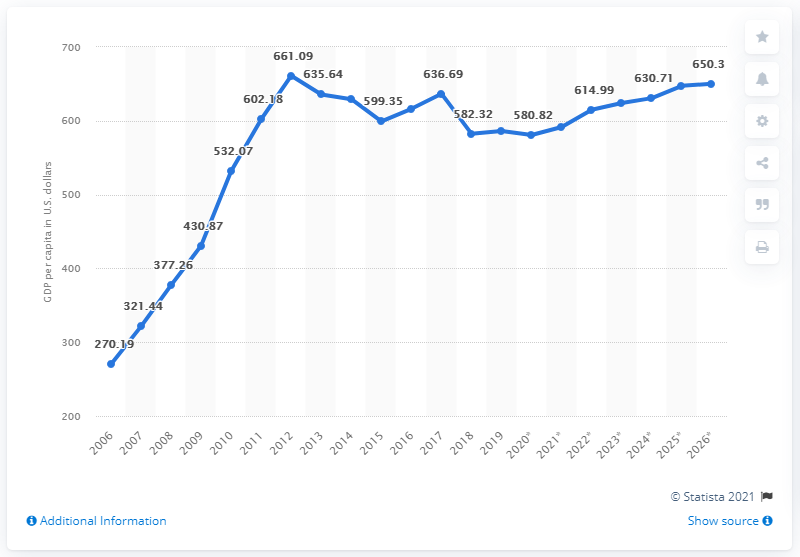Draw attention to some important aspects in this diagram. Afghanistan's GDP per capita was calculated in 2006. In 2019, Afghanistan's gross domestic product per capita was estimated to be $586.20 in dollars. This represents a significant increase from the previous year and indicates that the country's economy is continuing to grow and develop. 